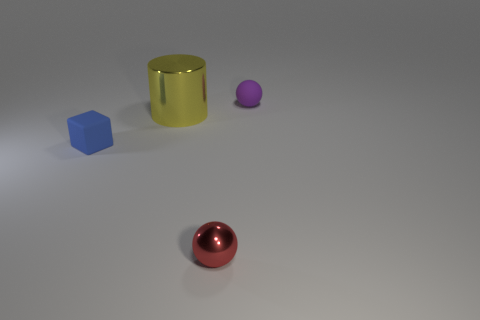Add 2 big cyan balls. How many objects exist? 6 Subtract all cylinders. How many objects are left? 3 Add 3 tiny purple matte things. How many tiny purple matte things exist? 4 Subtract 0 cyan cubes. How many objects are left? 4 Subtract all rubber balls. Subtract all yellow metallic cylinders. How many objects are left? 2 Add 4 tiny matte spheres. How many tiny matte spheres are left? 5 